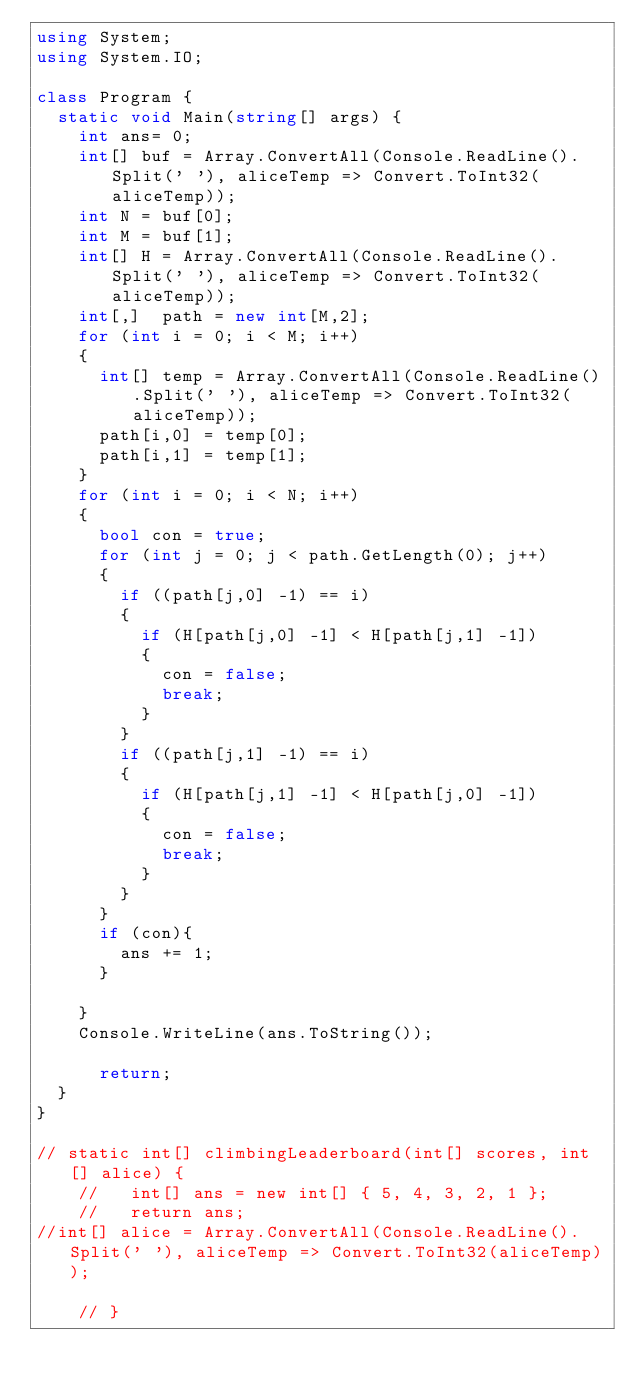Convert code to text. <code><loc_0><loc_0><loc_500><loc_500><_C#_>using System;
using System.IO;

class Program {
  static void Main(string[] args) {
    int ans= 0;
    int[] buf = Array.ConvertAll(Console.ReadLine().Split(' '), aliceTemp => Convert.ToInt32(aliceTemp));
    int N = buf[0];
    int M = buf[1];
    int[] H = Array.ConvertAll(Console.ReadLine().Split(' '), aliceTemp => Convert.ToInt32(aliceTemp));
    int[,]  path = new int[M,2];
    for (int i = 0; i < M; i++)
    {
      int[] temp = Array.ConvertAll(Console.ReadLine().Split(' '), aliceTemp => Convert.ToInt32(aliceTemp));
      path[i,0] = temp[0];    
      path[i,1] = temp[1];    
    }
    for (int i = 0; i < N; i++)
    { 
      bool con = true;
      for (int j = 0; j < path.GetLength(0); j++)
      {
        if ((path[j,0] -1) == i)
        {
          if (H[path[j,0] -1] < H[path[j,1] -1])
          {
            con = false;
            break;
          }
        }
        if ((path[j,1] -1) == i)
        {
          if (H[path[j,1] -1] < H[path[j,0] -1])
          {
            con = false;
            break;
          }
        }
      }
      if (con){
        ans += 1;
      }
    
    }
    Console.WriteLine(ans.ToString());

      return;
  }
}

// static int[] climbingLeaderboard(int[] scores, int[] alice) {
    //   int[] ans = new int[] { 5, 4, 3, 2, 1 };
    //   return ans;
//int[] alice = Array.ConvertAll(Console.ReadLine().Split(' '), aliceTemp => Convert.ToInt32(aliceTemp));

    // }</code> 